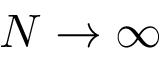<formula> <loc_0><loc_0><loc_500><loc_500>N \to \infty</formula> 